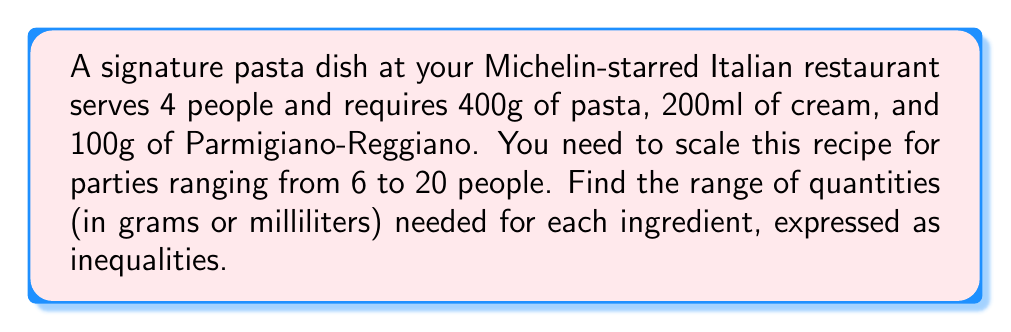Solve this math problem. Let's approach this step-by-step:

1) First, let's calculate the amount of each ingredient per person:
   Pasta: $400g ÷ 4 = 100g$ per person
   Cream: $200ml ÷ 4 = 50ml$ per person
   Parmigiano-Reggiano: $100g ÷ 4 = 25g$ per person

2) Now, we need to scale these amounts for parties ranging from 6 to 20 people.
   For 6 people (minimum):
   Pasta: $100g × 6 = 600g$
   Cream: $50ml × 6 = 300ml$
   Parmigiano-Reggiano: $25g × 6 = 150g$

   For 20 people (maximum):
   Pasta: $100g × 20 = 2000g$
   Cream: $50ml × 20 = 1000ml$
   Parmigiano-Reggiano: $25g × 20 = 500g$

3) We can express these ranges as inequalities:
   Pasta: $600g ≤ x ≤ 2000g$, where $x$ is the amount of pasta
   Cream: $300ml ≤ y ≤ 1000ml$, where $y$ is the amount of cream
   Parmigiano-Reggiano: $150g ≤ z ≤ 500g$, where $z$ is the amount of cheese

Therefore, the ranges of quantities needed for each ingredient, expressed as inequalities, are:

$$600 ≤ x ≤ 2000$$
$$300 ≤ y ≤ 1000$$
$$150 ≤ z ≤ 500$$

where $x$, $y$, and $z$ represent the amounts of pasta (g), cream (ml), and Parmigiano-Reggiano (g) respectively.
Answer: $$600 ≤ x ≤ 2000, 300 ≤ y ≤ 1000, 150 ≤ z ≤ 500$$ 